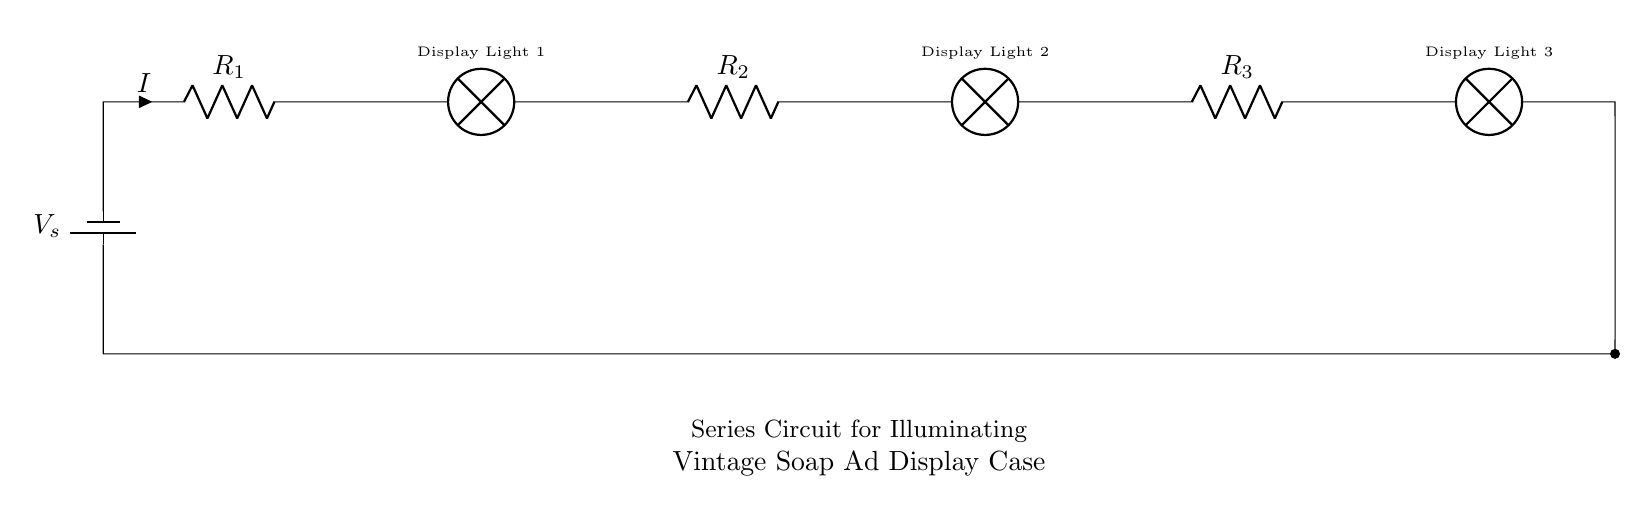What is the source voltage of the circuit? The source voltage is represented by \( V_s \) in the circuit diagram, indicating the potential difference provided by the battery connected in series.
Answer: \( V_s \) How many lamps are included in this circuit? There are three lamps shown in the circuit, each connected in series one after the other.
Answer: 3 What type of circuit is shown in the diagram? The diagram illustrates a series circuit, as evidenced by the arrangement of components where the same current flows through all elements sequentially.
Answer: Series What can be said about the current throughout this circuit? The current \( I \) is identical through each component in a series circuit, meaning each lamp and resistor has the same current passing through it.
Answer: Identical What are the components used for limiting current in this circuit? The circuit employs resistors \( R_1, R_2, \) and \( R_3 \) to limit the current flowing through the lamps.
Answer: Resistors What happens to the voltage across each lamp in a series circuit? In a series circuit, the total voltage is divided among the components, which means each lamp experiences a portion of the total voltage, dependent on their relative resistances.
Answer: Divided What does the connection of the lamps indicate about their status when the circuit is closed? The series connection implies that when the circuit is closed, all lamps will illuminate simultaneously, as current must pass through each component to complete the circuit.
Answer: Illuminate simultaneously 